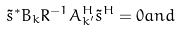<formula> <loc_0><loc_0><loc_500><loc_500>\tilde { s } ^ { * } B _ { k } R ^ { - 1 } A _ { k ^ { \prime } } ^ { H } \tilde { s } ^ { H } = 0 a n d</formula> 